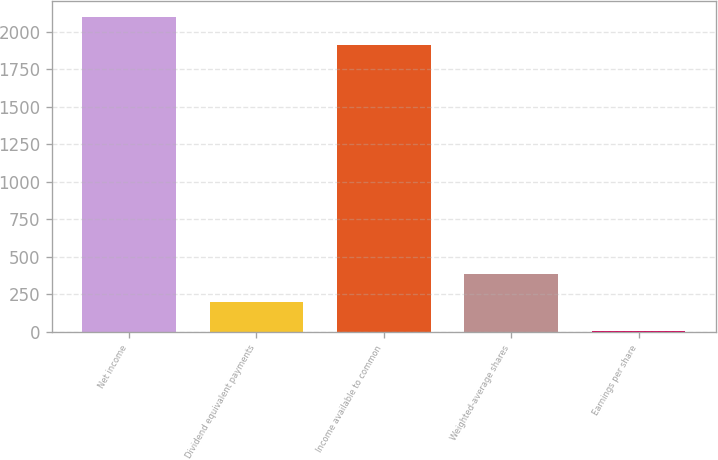Convert chart. <chart><loc_0><loc_0><loc_500><loc_500><bar_chart><fcel>Net income<fcel>Dividend equivalent payments<fcel>Income available to common<fcel>Weighted-average shares<fcel>Earnings per share<nl><fcel>2098.05<fcel>196.57<fcel>1907<fcel>387.62<fcel>5.52<nl></chart> 